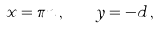<formula> <loc_0><loc_0><loc_500><loc_500>x = \pi n \, , \quad y = - d \, ,</formula> 